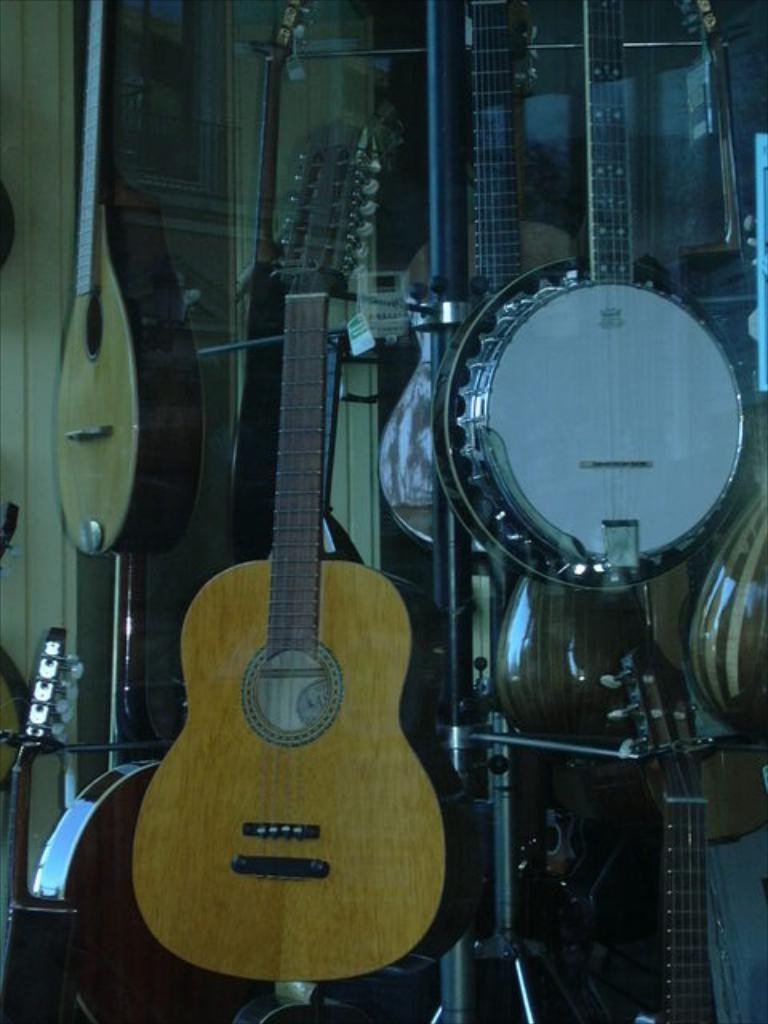Describe this image in one or two sentences. In the picture we can see some musical instruments like guitar, violin and some instruments in it. 